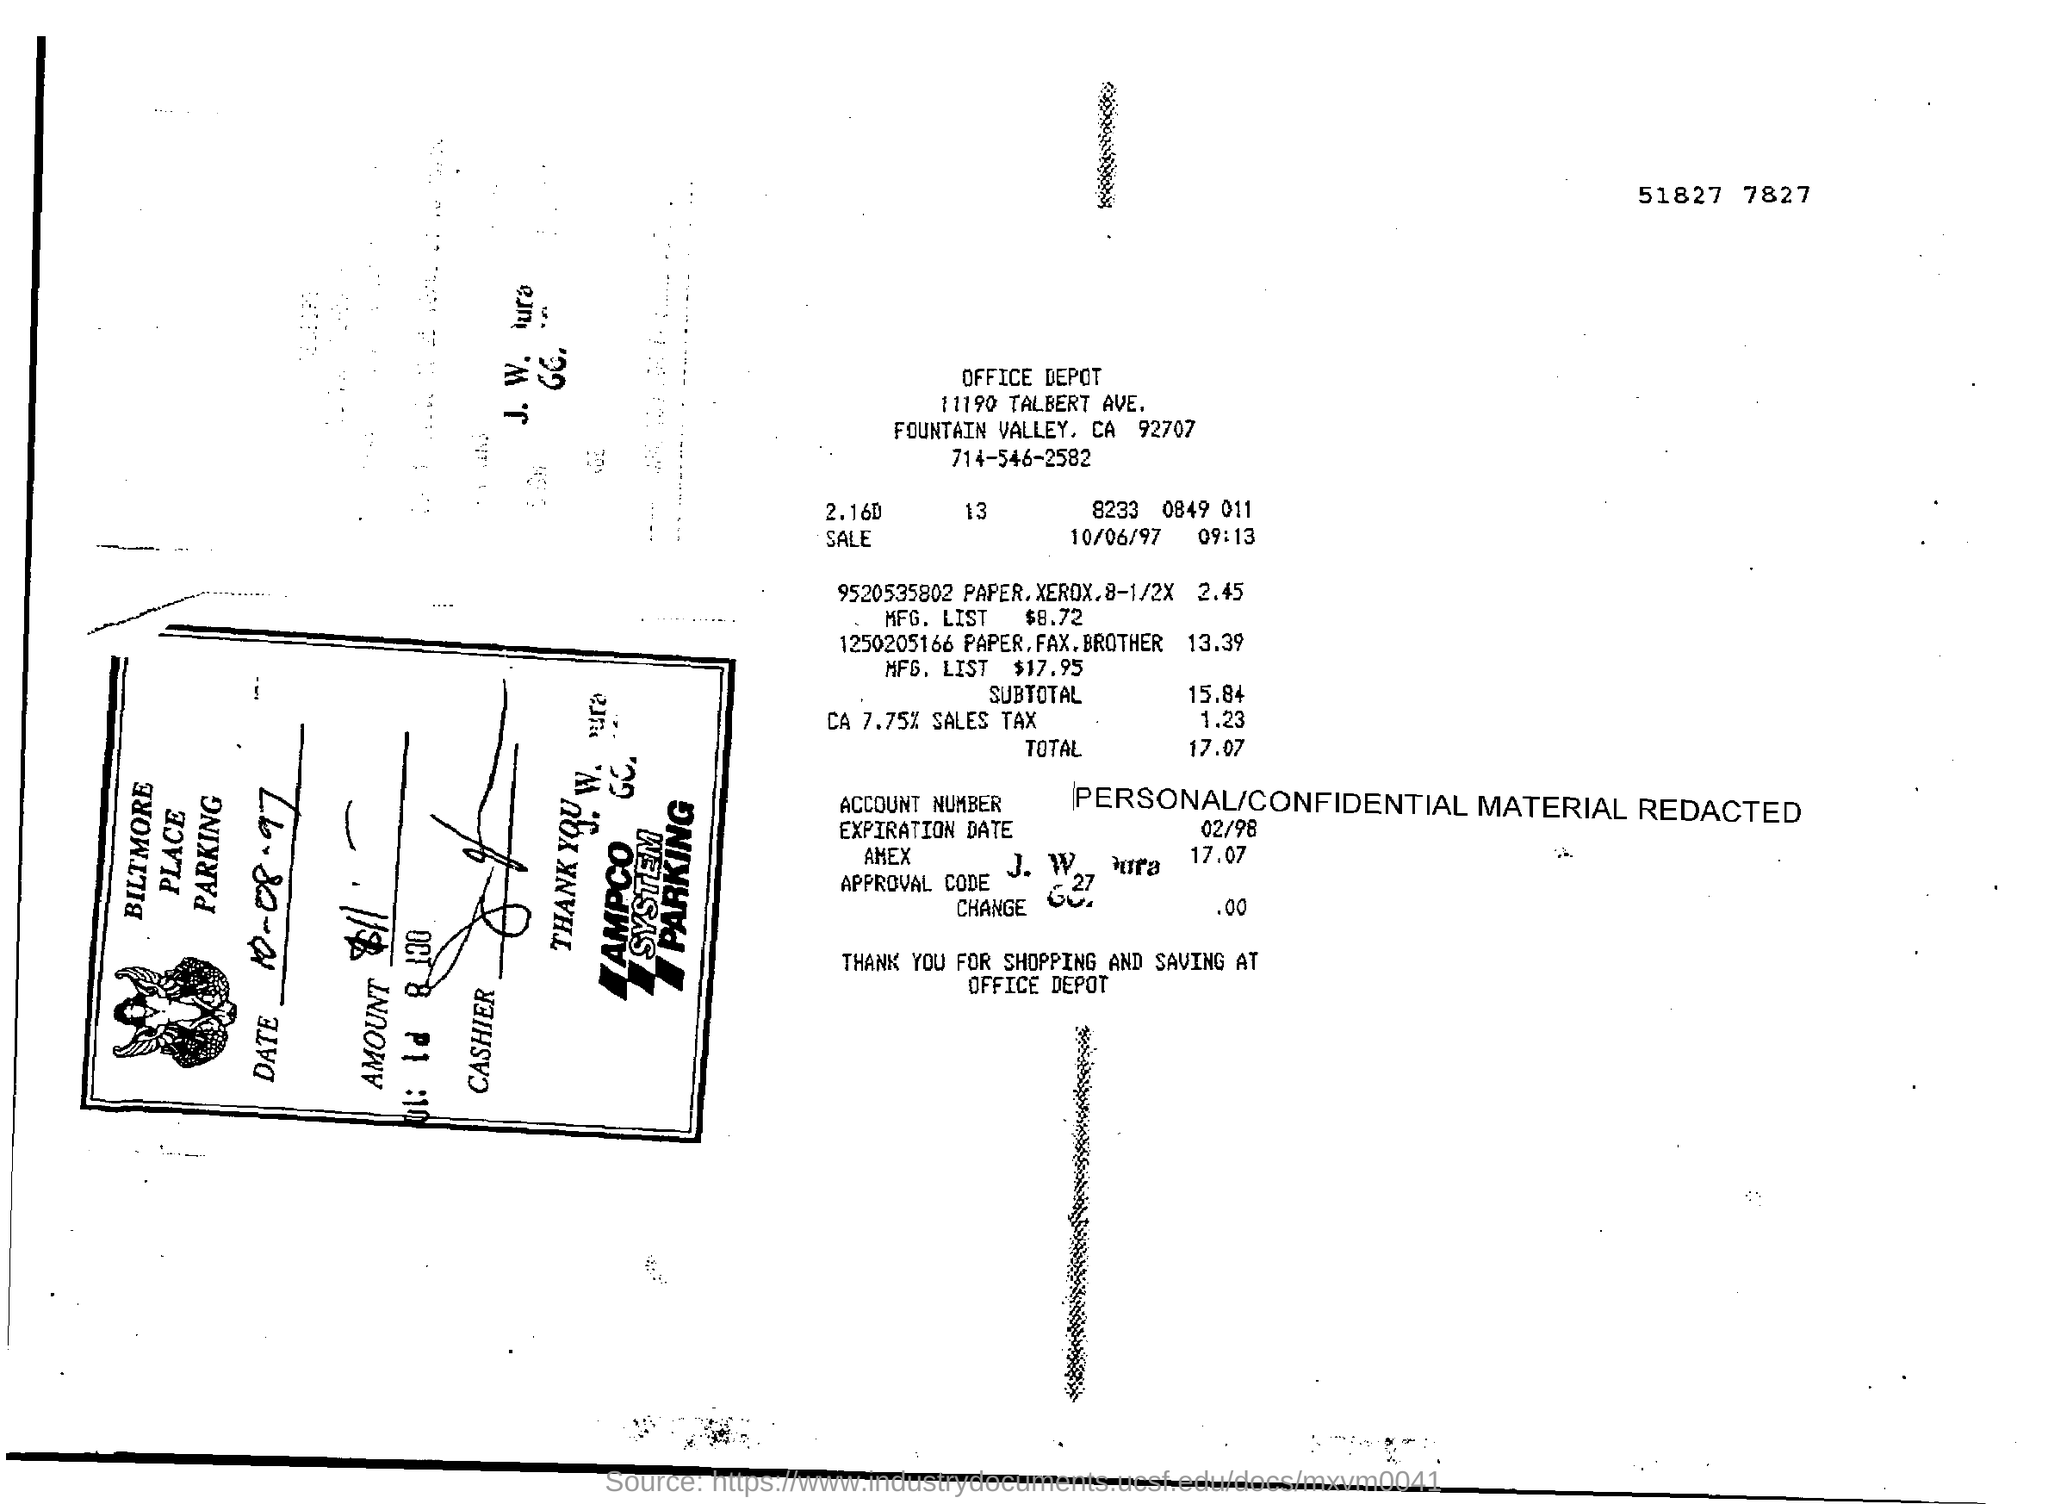Outline some significant characteristics in this image. The total is 17.07 [or 'amount is'] 